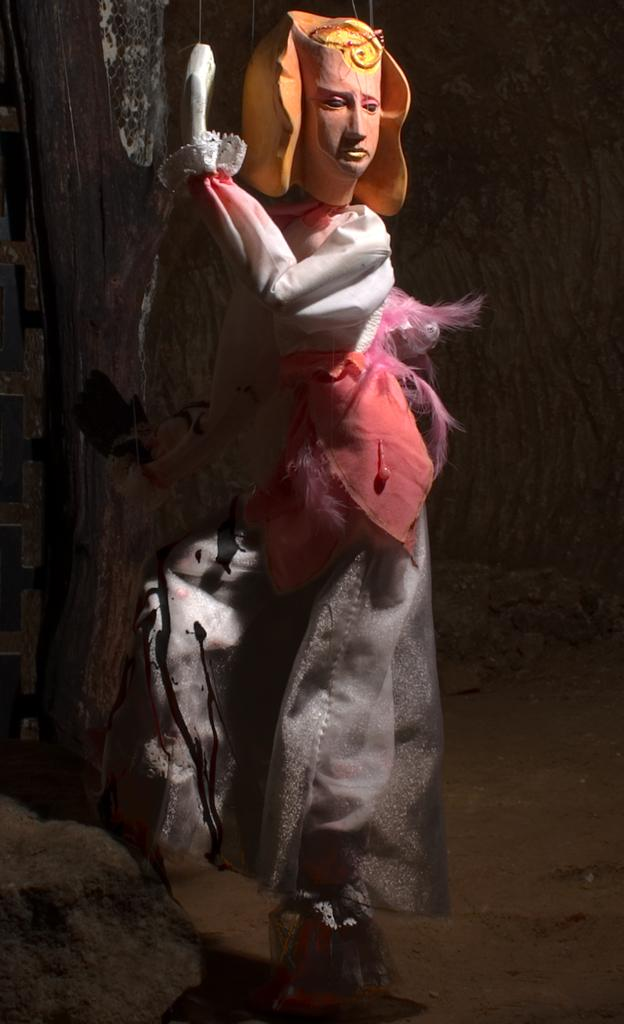What is the main subject of the image? The main subject of the image is a sculptor. How is the sculptor dressed in the image? The sculptor is wearing a different costume in the image. What can be seen near the sculptor in the image? There is a rock to the side of the sculptor in the image. What type of berry is growing on the sculptor's head in the image? There are no berries present on the sculptor's head in the image. Can you tell me how many books are in the library behind the sculptor in the image? There is no library present in the image; it features a sculptor and a rock. 